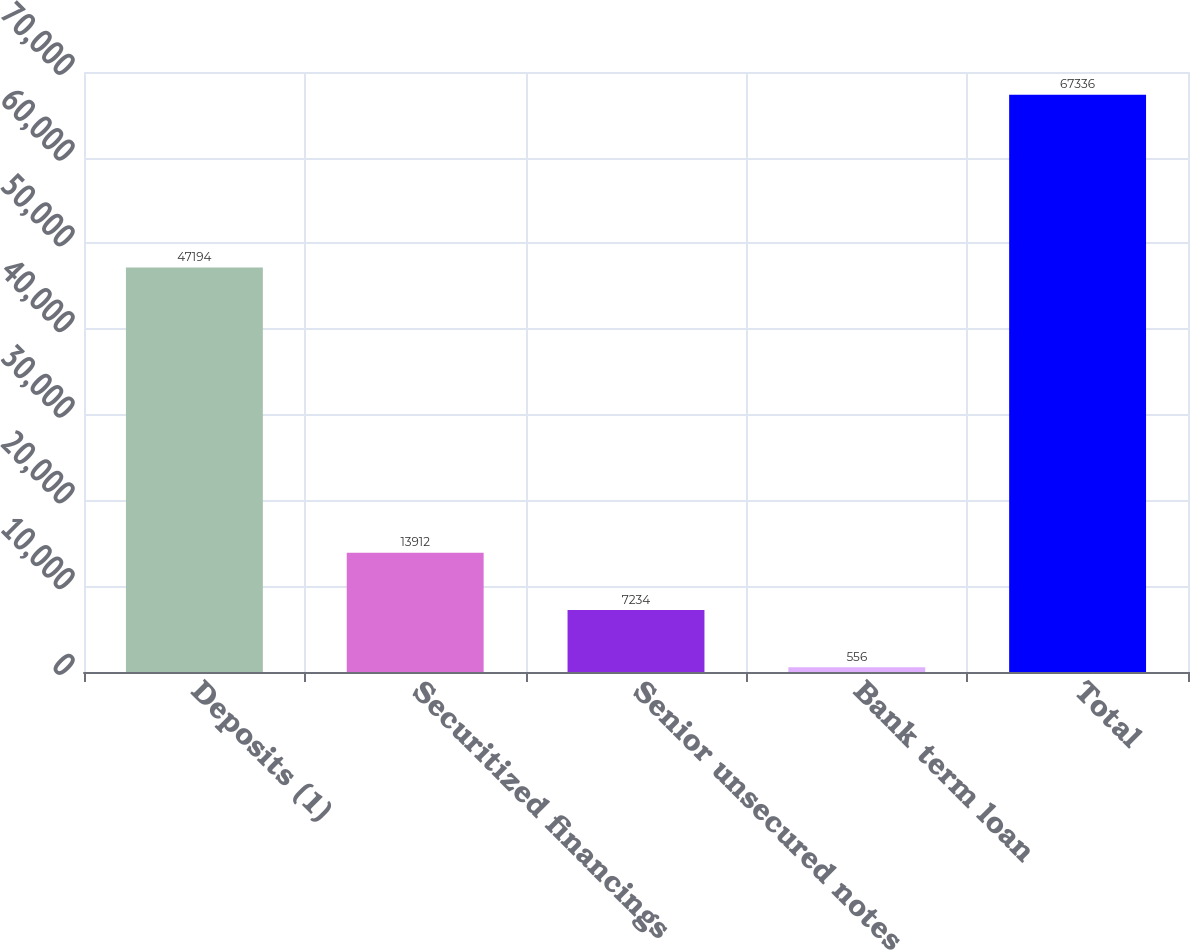<chart> <loc_0><loc_0><loc_500><loc_500><bar_chart><fcel>Deposits (1)<fcel>Securitized financings<fcel>Senior unsecured notes<fcel>Bank term loan<fcel>Total<nl><fcel>47194<fcel>13912<fcel>7234<fcel>556<fcel>67336<nl></chart> 